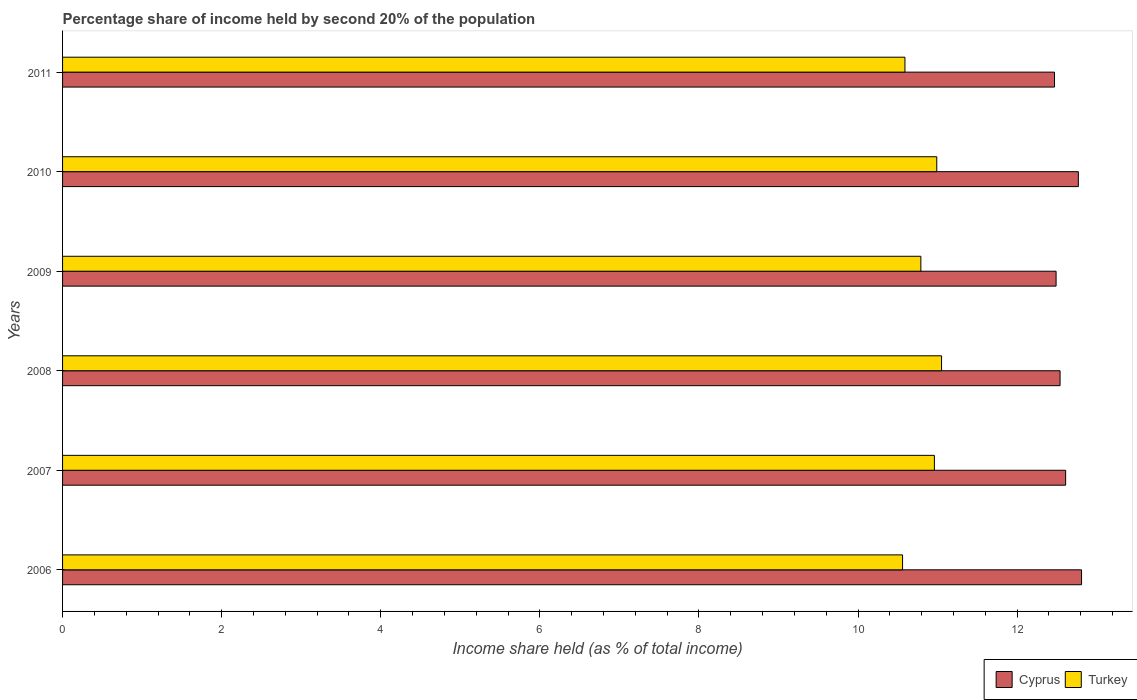How many groups of bars are there?
Provide a succinct answer. 6. Are the number of bars per tick equal to the number of legend labels?
Offer a very short reply. Yes. Are the number of bars on each tick of the Y-axis equal?
Keep it short and to the point. Yes. How many bars are there on the 5th tick from the bottom?
Your answer should be compact. 2. What is the share of income held by second 20% of the population in Cyprus in 2011?
Your response must be concise. 12.47. Across all years, what is the maximum share of income held by second 20% of the population in Turkey?
Your answer should be compact. 11.05. Across all years, what is the minimum share of income held by second 20% of the population in Cyprus?
Offer a very short reply. 12.47. In which year was the share of income held by second 20% of the population in Cyprus minimum?
Provide a short and direct response. 2011. What is the total share of income held by second 20% of the population in Cyprus in the graph?
Offer a terse response. 75.69. What is the difference between the share of income held by second 20% of the population in Turkey in 2007 and that in 2011?
Provide a short and direct response. 0.37. What is the difference between the share of income held by second 20% of the population in Turkey in 2011 and the share of income held by second 20% of the population in Cyprus in 2008?
Ensure brevity in your answer.  -1.95. What is the average share of income held by second 20% of the population in Cyprus per year?
Your answer should be compact. 12.62. In the year 2006, what is the difference between the share of income held by second 20% of the population in Turkey and share of income held by second 20% of the population in Cyprus?
Provide a short and direct response. -2.25. In how many years, is the share of income held by second 20% of the population in Cyprus greater than 5.6 %?
Ensure brevity in your answer.  6. What is the ratio of the share of income held by second 20% of the population in Cyprus in 2008 to that in 2010?
Make the answer very short. 0.98. Is the share of income held by second 20% of the population in Turkey in 2007 less than that in 2011?
Your answer should be compact. No. What is the difference between the highest and the second highest share of income held by second 20% of the population in Turkey?
Provide a succinct answer. 0.06. What is the difference between the highest and the lowest share of income held by second 20% of the population in Turkey?
Your answer should be compact. 0.49. In how many years, is the share of income held by second 20% of the population in Cyprus greater than the average share of income held by second 20% of the population in Cyprus taken over all years?
Offer a terse response. 2. Is the sum of the share of income held by second 20% of the population in Cyprus in 2006 and 2010 greater than the maximum share of income held by second 20% of the population in Turkey across all years?
Keep it short and to the point. Yes. What does the 1st bar from the top in 2011 represents?
Your answer should be very brief. Turkey. What does the 1st bar from the bottom in 2010 represents?
Keep it short and to the point. Cyprus. Are all the bars in the graph horizontal?
Your answer should be compact. Yes. Does the graph contain grids?
Offer a terse response. No. How many legend labels are there?
Offer a very short reply. 2. What is the title of the graph?
Your answer should be compact. Percentage share of income held by second 20% of the population. Does "Ethiopia" appear as one of the legend labels in the graph?
Provide a short and direct response. No. What is the label or title of the X-axis?
Make the answer very short. Income share held (as % of total income). What is the Income share held (as % of total income) in Cyprus in 2006?
Offer a terse response. 12.81. What is the Income share held (as % of total income) in Turkey in 2006?
Make the answer very short. 10.56. What is the Income share held (as % of total income) of Cyprus in 2007?
Ensure brevity in your answer.  12.61. What is the Income share held (as % of total income) in Turkey in 2007?
Give a very brief answer. 10.96. What is the Income share held (as % of total income) of Cyprus in 2008?
Provide a short and direct response. 12.54. What is the Income share held (as % of total income) of Turkey in 2008?
Offer a very short reply. 11.05. What is the Income share held (as % of total income) in Cyprus in 2009?
Provide a succinct answer. 12.49. What is the Income share held (as % of total income) in Turkey in 2009?
Your answer should be compact. 10.79. What is the Income share held (as % of total income) in Cyprus in 2010?
Your response must be concise. 12.77. What is the Income share held (as % of total income) of Turkey in 2010?
Offer a terse response. 10.99. What is the Income share held (as % of total income) in Cyprus in 2011?
Offer a terse response. 12.47. What is the Income share held (as % of total income) of Turkey in 2011?
Provide a succinct answer. 10.59. Across all years, what is the maximum Income share held (as % of total income) of Cyprus?
Provide a short and direct response. 12.81. Across all years, what is the maximum Income share held (as % of total income) of Turkey?
Provide a succinct answer. 11.05. Across all years, what is the minimum Income share held (as % of total income) in Cyprus?
Provide a short and direct response. 12.47. Across all years, what is the minimum Income share held (as % of total income) in Turkey?
Make the answer very short. 10.56. What is the total Income share held (as % of total income) of Cyprus in the graph?
Give a very brief answer. 75.69. What is the total Income share held (as % of total income) in Turkey in the graph?
Your response must be concise. 64.94. What is the difference between the Income share held (as % of total income) of Cyprus in 2006 and that in 2008?
Offer a very short reply. 0.27. What is the difference between the Income share held (as % of total income) in Turkey in 2006 and that in 2008?
Ensure brevity in your answer.  -0.49. What is the difference between the Income share held (as % of total income) of Cyprus in 2006 and that in 2009?
Provide a succinct answer. 0.32. What is the difference between the Income share held (as % of total income) of Turkey in 2006 and that in 2009?
Ensure brevity in your answer.  -0.23. What is the difference between the Income share held (as % of total income) in Cyprus in 2006 and that in 2010?
Provide a succinct answer. 0.04. What is the difference between the Income share held (as % of total income) in Turkey in 2006 and that in 2010?
Your answer should be very brief. -0.43. What is the difference between the Income share held (as % of total income) in Cyprus in 2006 and that in 2011?
Make the answer very short. 0.34. What is the difference between the Income share held (as % of total income) of Turkey in 2006 and that in 2011?
Offer a very short reply. -0.03. What is the difference between the Income share held (as % of total income) in Cyprus in 2007 and that in 2008?
Your answer should be very brief. 0.07. What is the difference between the Income share held (as % of total income) of Turkey in 2007 and that in 2008?
Offer a very short reply. -0.09. What is the difference between the Income share held (as % of total income) of Cyprus in 2007 and that in 2009?
Your answer should be very brief. 0.12. What is the difference between the Income share held (as % of total income) of Turkey in 2007 and that in 2009?
Give a very brief answer. 0.17. What is the difference between the Income share held (as % of total income) in Cyprus in 2007 and that in 2010?
Make the answer very short. -0.16. What is the difference between the Income share held (as % of total income) in Turkey in 2007 and that in 2010?
Give a very brief answer. -0.03. What is the difference between the Income share held (as % of total income) in Cyprus in 2007 and that in 2011?
Make the answer very short. 0.14. What is the difference between the Income share held (as % of total income) of Turkey in 2007 and that in 2011?
Offer a terse response. 0.37. What is the difference between the Income share held (as % of total income) in Cyprus in 2008 and that in 2009?
Offer a terse response. 0.05. What is the difference between the Income share held (as % of total income) of Turkey in 2008 and that in 2009?
Provide a short and direct response. 0.26. What is the difference between the Income share held (as % of total income) in Cyprus in 2008 and that in 2010?
Your answer should be compact. -0.23. What is the difference between the Income share held (as % of total income) in Cyprus in 2008 and that in 2011?
Offer a very short reply. 0.07. What is the difference between the Income share held (as % of total income) of Turkey in 2008 and that in 2011?
Give a very brief answer. 0.46. What is the difference between the Income share held (as % of total income) of Cyprus in 2009 and that in 2010?
Your response must be concise. -0.28. What is the difference between the Income share held (as % of total income) in Turkey in 2009 and that in 2011?
Your answer should be very brief. 0.2. What is the difference between the Income share held (as % of total income) in Cyprus in 2010 and that in 2011?
Offer a terse response. 0.3. What is the difference between the Income share held (as % of total income) of Cyprus in 2006 and the Income share held (as % of total income) of Turkey in 2007?
Ensure brevity in your answer.  1.85. What is the difference between the Income share held (as % of total income) of Cyprus in 2006 and the Income share held (as % of total income) of Turkey in 2008?
Ensure brevity in your answer.  1.76. What is the difference between the Income share held (as % of total income) in Cyprus in 2006 and the Income share held (as % of total income) in Turkey in 2009?
Your response must be concise. 2.02. What is the difference between the Income share held (as % of total income) in Cyprus in 2006 and the Income share held (as % of total income) in Turkey in 2010?
Your answer should be compact. 1.82. What is the difference between the Income share held (as % of total income) in Cyprus in 2006 and the Income share held (as % of total income) in Turkey in 2011?
Provide a succinct answer. 2.22. What is the difference between the Income share held (as % of total income) in Cyprus in 2007 and the Income share held (as % of total income) in Turkey in 2008?
Your response must be concise. 1.56. What is the difference between the Income share held (as % of total income) of Cyprus in 2007 and the Income share held (as % of total income) of Turkey in 2009?
Make the answer very short. 1.82. What is the difference between the Income share held (as % of total income) of Cyprus in 2007 and the Income share held (as % of total income) of Turkey in 2010?
Your answer should be compact. 1.62. What is the difference between the Income share held (as % of total income) in Cyprus in 2007 and the Income share held (as % of total income) in Turkey in 2011?
Give a very brief answer. 2.02. What is the difference between the Income share held (as % of total income) in Cyprus in 2008 and the Income share held (as % of total income) in Turkey in 2009?
Offer a terse response. 1.75. What is the difference between the Income share held (as % of total income) of Cyprus in 2008 and the Income share held (as % of total income) of Turkey in 2010?
Ensure brevity in your answer.  1.55. What is the difference between the Income share held (as % of total income) of Cyprus in 2008 and the Income share held (as % of total income) of Turkey in 2011?
Offer a very short reply. 1.95. What is the difference between the Income share held (as % of total income) of Cyprus in 2009 and the Income share held (as % of total income) of Turkey in 2011?
Give a very brief answer. 1.9. What is the difference between the Income share held (as % of total income) in Cyprus in 2010 and the Income share held (as % of total income) in Turkey in 2011?
Your answer should be compact. 2.18. What is the average Income share held (as % of total income) in Cyprus per year?
Provide a short and direct response. 12.62. What is the average Income share held (as % of total income) of Turkey per year?
Your answer should be compact. 10.82. In the year 2006, what is the difference between the Income share held (as % of total income) in Cyprus and Income share held (as % of total income) in Turkey?
Provide a short and direct response. 2.25. In the year 2007, what is the difference between the Income share held (as % of total income) of Cyprus and Income share held (as % of total income) of Turkey?
Give a very brief answer. 1.65. In the year 2008, what is the difference between the Income share held (as % of total income) in Cyprus and Income share held (as % of total income) in Turkey?
Ensure brevity in your answer.  1.49. In the year 2009, what is the difference between the Income share held (as % of total income) in Cyprus and Income share held (as % of total income) in Turkey?
Offer a very short reply. 1.7. In the year 2010, what is the difference between the Income share held (as % of total income) in Cyprus and Income share held (as % of total income) in Turkey?
Your response must be concise. 1.78. In the year 2011, what is the difference between the Income share held (as % of total income) in Cyprus and Income share held (as % of total income) in Turkey?
Provide a short and direct response. 1.88. What is the ratio of the Income share held (as % of total income) of Cyprus in 2006 to that in 2007?
Give a very brief answer. 1.02. What is the ratio of the Income share held (as % of total income) in Turkey in 2006 to that in 2007?
Make the answer very short. 0.96. What is the ratio of the Income share held (as % of total income) in Cyprus in 2006 to that in 2008?
Offer a terse response. 1.02. What is the ratio of the Income share held (as % of total income) of Turkey in 2006 to that in 2008?
Provide a succinct answer. 0.96. What is the ratio of the Income share held (as % of total income) in Cyprus in 2006 to that in 2009?
Make the answer very short. 1.03. What is the ratio of the Income share held (as % of total income) in Turkey in 2006 to that in 2009?
Give a very brief answer. 0.98. What is the ratio of the Income share held (as % of total income) of Turkey in 2006 to that in 2010?
Offer a very short reply. 0.96. What is the ratio of the Income share held (as % of total income) in Cyprus in 2006 to that in 2011?
Provide a succinct answer. 1.03. What is the ratio of the Income share held (as % of total income) in Turkey in 2006 to that in 2011?
Keep it short and to the point. 1. What is the ratio of the Income share held (as % of total income) of Cyprus in 2007 to that in 2008?
Give a very brief answer. 1.01. What is the ratio of the Income share held (as % of total income) of Cyprus in 2007 to that in 2009?
Offer a very short reply. 1.01. What is the ratio of the Income share held (as % of total income) in Turkey in 2007 to that in 2009?
Offer a terse response. 1.02. What is the ratio of the Income share held (as % of total income) of Cyprus in 2007 to that in 2010?
Offer a very short reply. 0.99. What is the ratio of the Income share held (as % of total income) in Cyprus in 2007 to that in 2011?
Your answer should be compact. 1.01. What is the ratio of the Income share held (as % of total income) of Turkey in 2007 to that in 2011?
Your answer should be compact. 1.03. What is the ratio of the Income share held (as % of total income) in Turkey in 2008 to that in 2009?
Offer a very short reply. 1.02. What is the ratio of the Income share held (as % of total income) in Turkey in 2008 to that in 2010?
Offer a terse response. 1.01. What is the ratio of the Income share held (as % of total income) of Cyprus in 2008 to that in 2011?
Make the answer very short. 1.01. What is the ratio of the Income share held (as % of total income) in Turkey in 2008 to that in 2011?
Your answer should be compact. 1.04. What is the ratio of the Income share held (as % of total income) of Cyprus in 2009 to that in 2010?
Offer a terse response. 0.98. What is the ratio of the Income share held (as % of total income) of Turkey in 2009 to that in 2010?
Your answer should be compact. 0.98. What is the ratio of the Income share held (as % of total income) in Cyprus in 2009 to that in 2011?
Ensure brevity in your answer.  1. What is the ratio of the Income share held (as % of total income) of Turkey in 2009 to that in 2011?
Keep it short and to the point. 1.02. What is the ratio of the Income share held (as % of total income) of Cyprus in 2010 to that in 2011?
Offer a terse response. 1.02. What is the ratio of the Income share held (as % of total income) of Turkey in 2010 to that in 2011?
Ensure brevity in your answer.  1.04. What is the difference between the highest and the second highest Income share held (as % of total income) in Cyprus?
Your answer should be very brief. 0.04. What is the difference between the highest and the second highest Income share held (as % of total income) of Turkey?
Offer a terse response. 0.06. What is the difference between the highest and the lowest Income share held (as % of total income) of Cyprus?
Offer a very short reply. 0.34. What is the difference between the highest and the lowest Income share held (as % of total income) of Turkey?
Offer a very short reply. 0.49. 